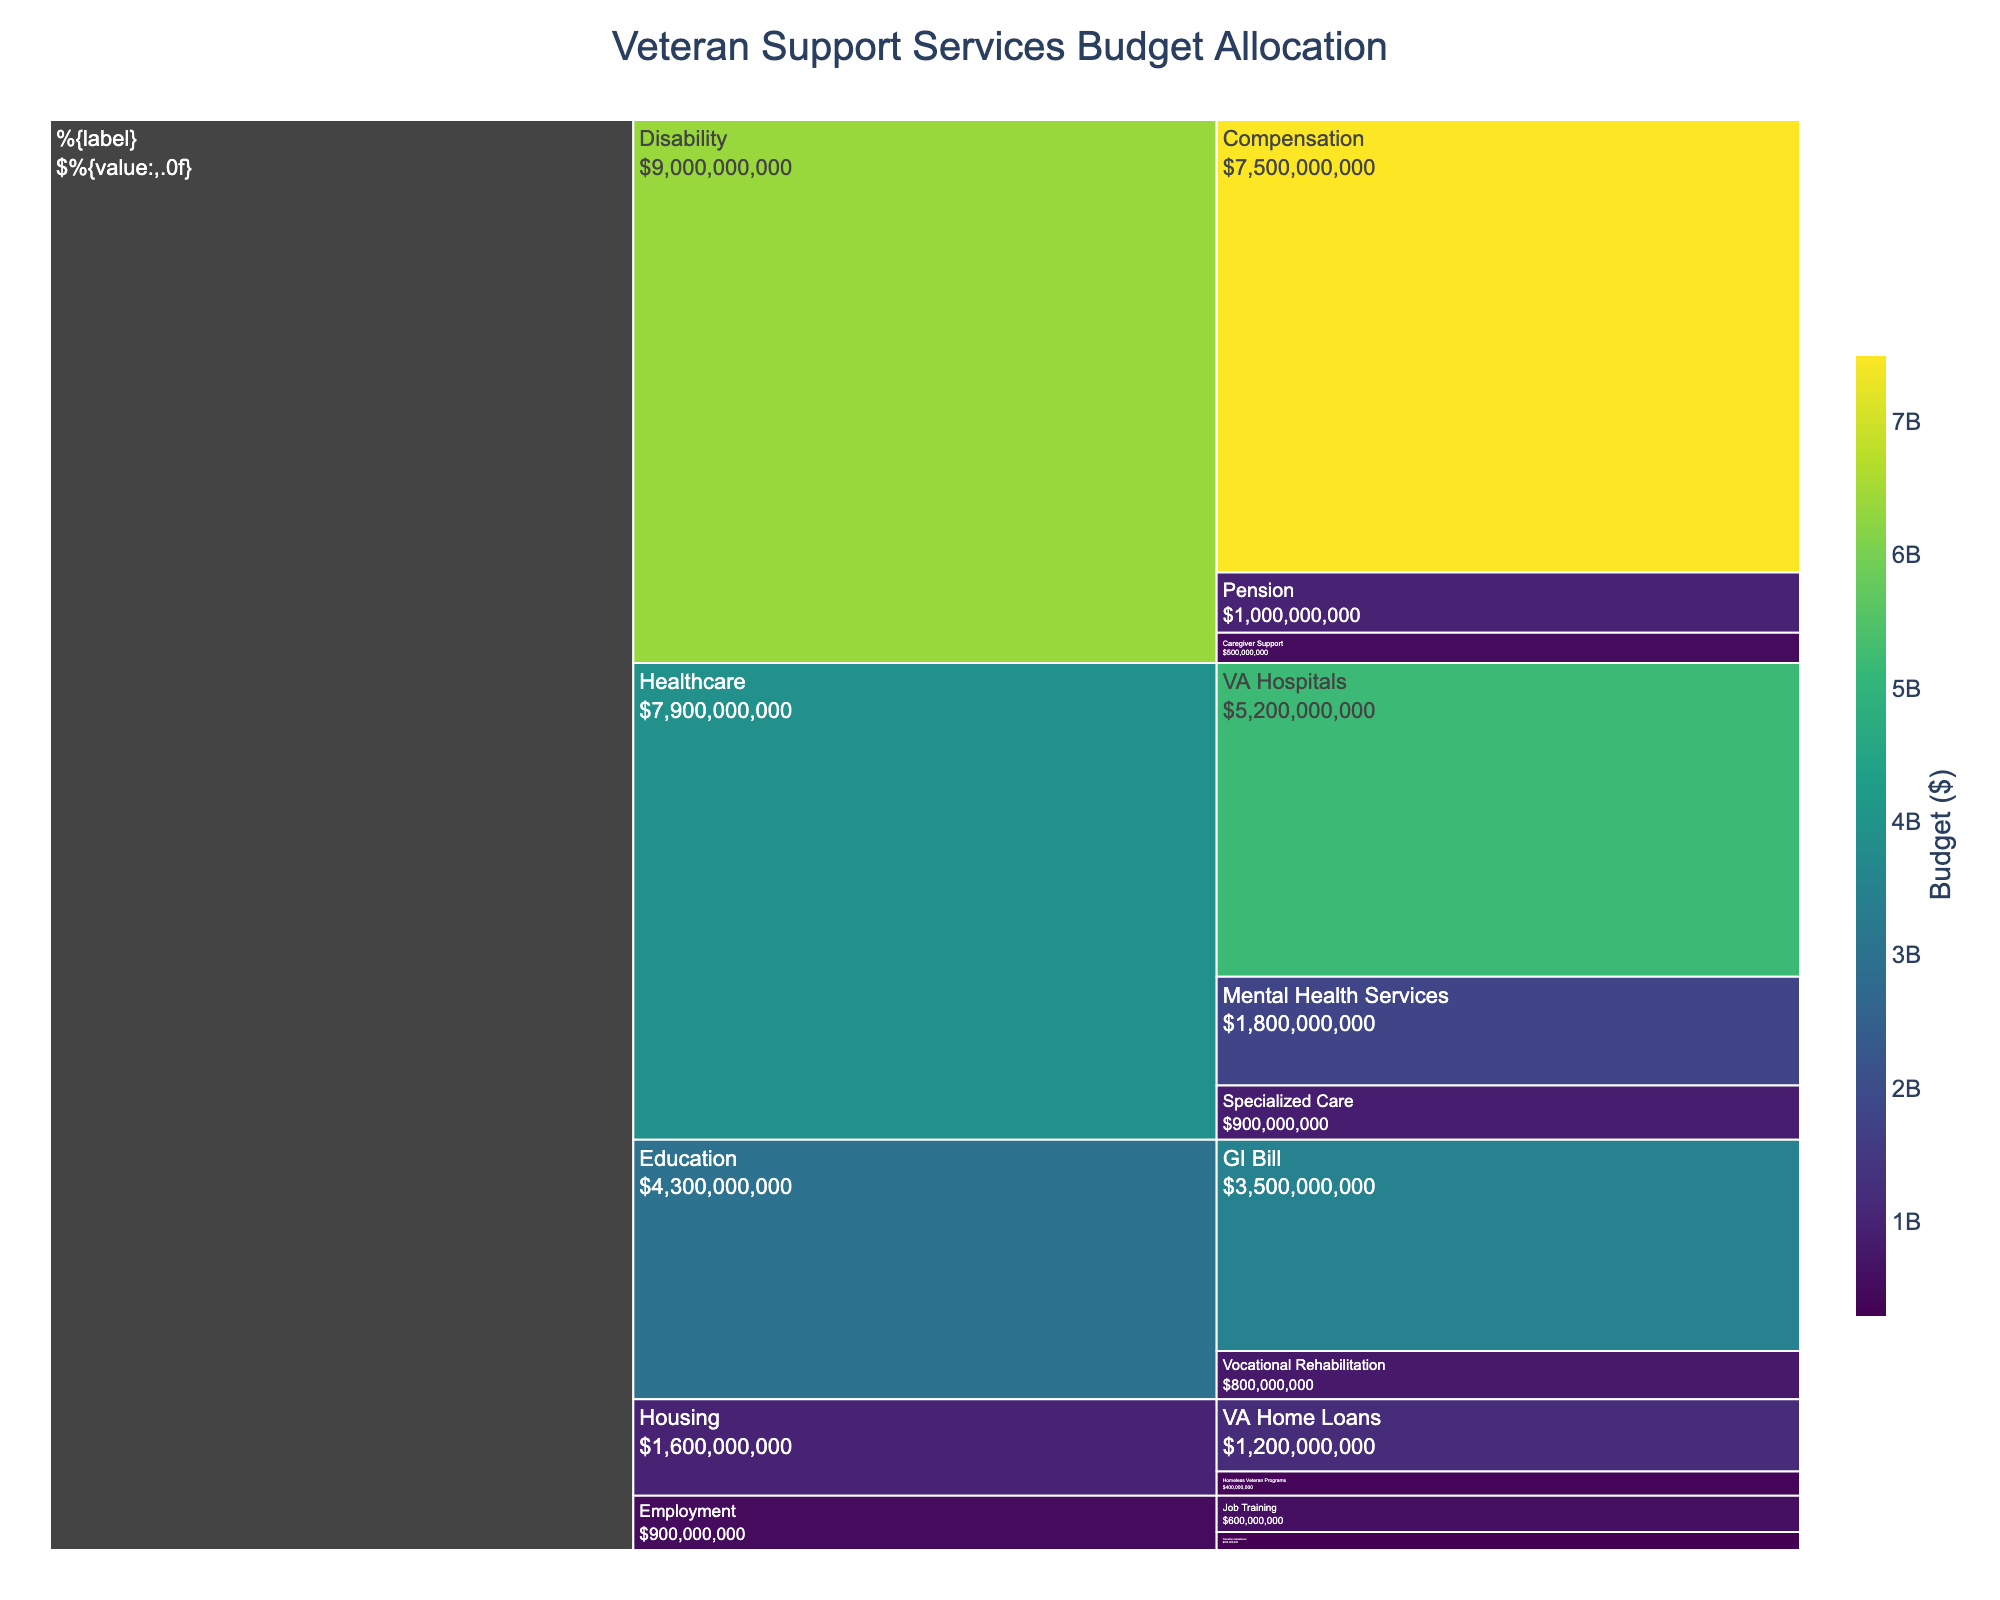What is the total budget for the Healthcare category? Add up the budgets for VA Hospitals, Mental Health Services, and Specialized Care. VA Hospitals: $5,200,000,000, Mental Health Services: $1,800,000,000, Specialized Care: $900,000,000. Total: $5,200,000,000 + $1,800,000,000 + $900,000,000 = $7,900,000,000
Answer: $7,900,000,000 Which subcategory within the Disability category has the largest budget? Compare the budgets of Compensation, Pension, and Caregiver Support. Compensation: $7,500,000,000 is the largest.
Answer: Compensation How much more is allocated to VA Hospitals compared to GI Bill? Calculate the difference between VA Hospitals and GI Bill. VA Hospitals: $5,200,000,000 minus GI Bill: $3,500,000,000. Difference: $5,200,000,000 - $3,500,000,000 = $1,700,000,000
Answer: $1,700,000,000 Which category receives the highest total budget allocation? Compare the total budgets of Healthcare, Education, Housing, Employment, and Disability. Disability has the highest total budget of $8,500,000,000.
Answer: Disability What is the combined budget for the subcategories within the Housing category? Add up the budgets for VA Home Loans and Homeless Veteran Programs. VA Home Loans: $1,200,000,000, Homeless Veteran Programs: $400,000,000. Combined: $1,200,000,000 + $400,000,000 = $1,600,000,000
Answer: $1,600,000,000 How does the budget for Mental Health Services compare to the budget for Job Training? Compare the budgets of Mental Health Services ($1,800,000,000) and Job Training ($600,000,000). $1,800,000,000 is greater than $600,000,000.
Answer: Mental Health Services has a larger budget What is the budget breakdown for the category with the lowest total allocation? Identify the category with the lowest total budget. Employment ($900,000,000). Breakdown: Job Training: $600,000,000, Transition Assistance: $300,000,000.
Answer: Job Training: $600,000,000, Transition Assistance: $300,000,000 Which subcategories have a budget under $1 billion? Identify subcategories with budgets less than $1 billion: Specialized Care ($900,000,000), Vocational Rehabilitation ($800,000,000), VA Home Loans ($1,200,000,000), Homeless Veteran Programs ($400,000,000), Job Training ($600,000,000), Transition Assistance ($300,000,000), Pension ($1,000,000,000), Caregiver Support ($500,000,000).
Answer: Specialized Care, Vocational Rehabilitation, Homeless Veteran Programs, Job Training, Transition Assistance, Caregiver Support How much more budget is allocated to Compensation than to the entire Housing category? Calculate the difference between Compensation ($7,500,000,000) and Housing ($1,600,000,000). Difference: $7,500,000,000 - $1,600,000,000 = $5,900,000,000
Answer: $5,900,000,000 